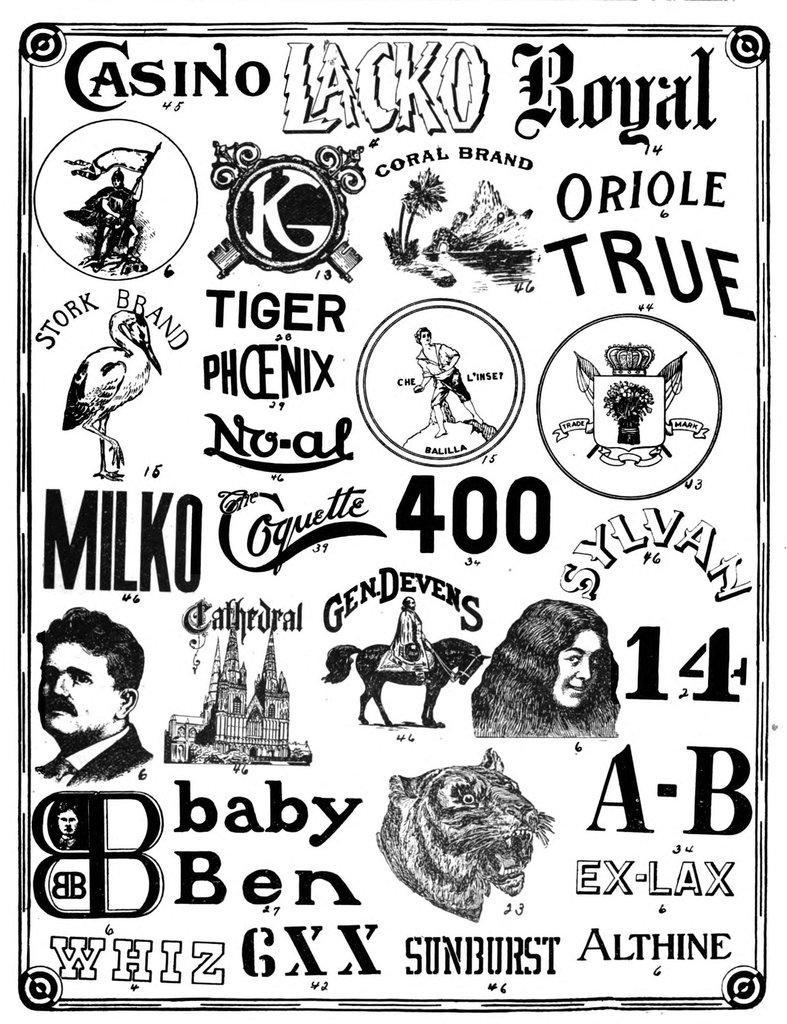In one or two sentences, can you explain what this image depicts? In this image there is a poster with the logos and some pictures in it. 